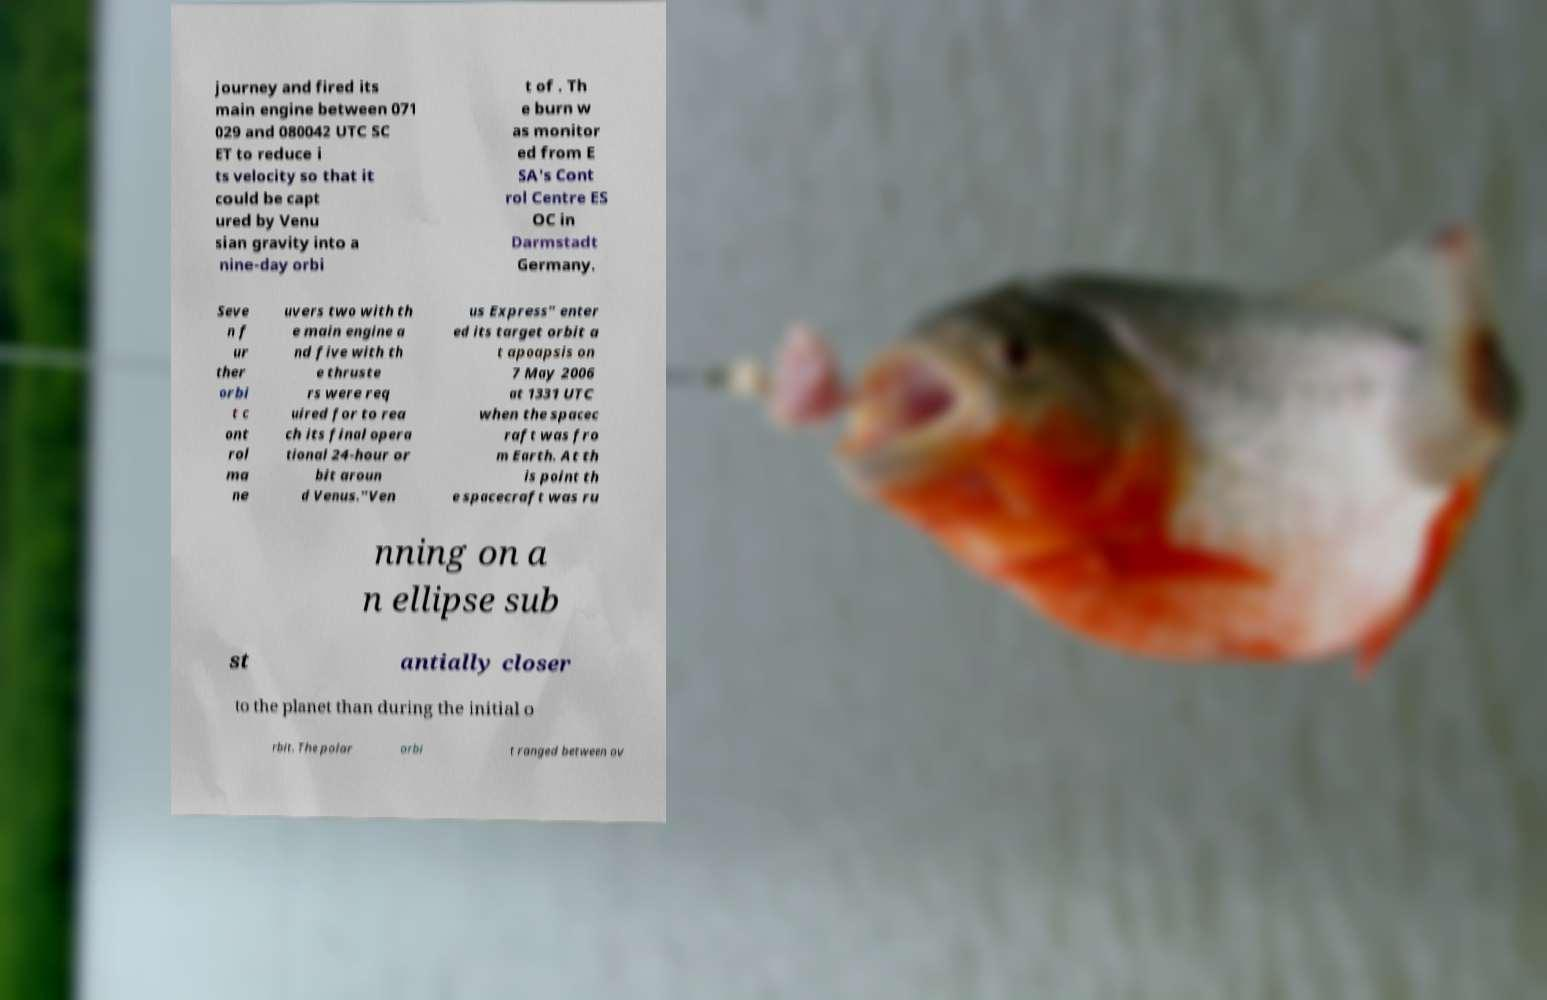Please identify and transcribe the text found in this image. journey and fired its main engine between 071 029 and 080042 UTC SC ET to reduce i ts velocity so that it could be capt ured by Venu sian gravity into a nine-day orbi t of . Th e burn w as monitor ed from E SA's Cont rol Centre ES OC in Darmstadt Germany. Seve n f ur ther orbi t c ont rol ma ne uvers two with th e main engine a nd five with th e thruste rs were req uired for to rea ch its final opera tional 24-hour or bit aroun d Venus."Ven us Express" enter ed its target orbit a t apoapsis on 7 May 2006 at 1331 UTC when the spacec raft was fro m Earth. At th is point th e spacecraft was ru nning on a n ellipse sub st antially closer to the planet than during the initial o rbit. The polar orbi t ranged between ov 